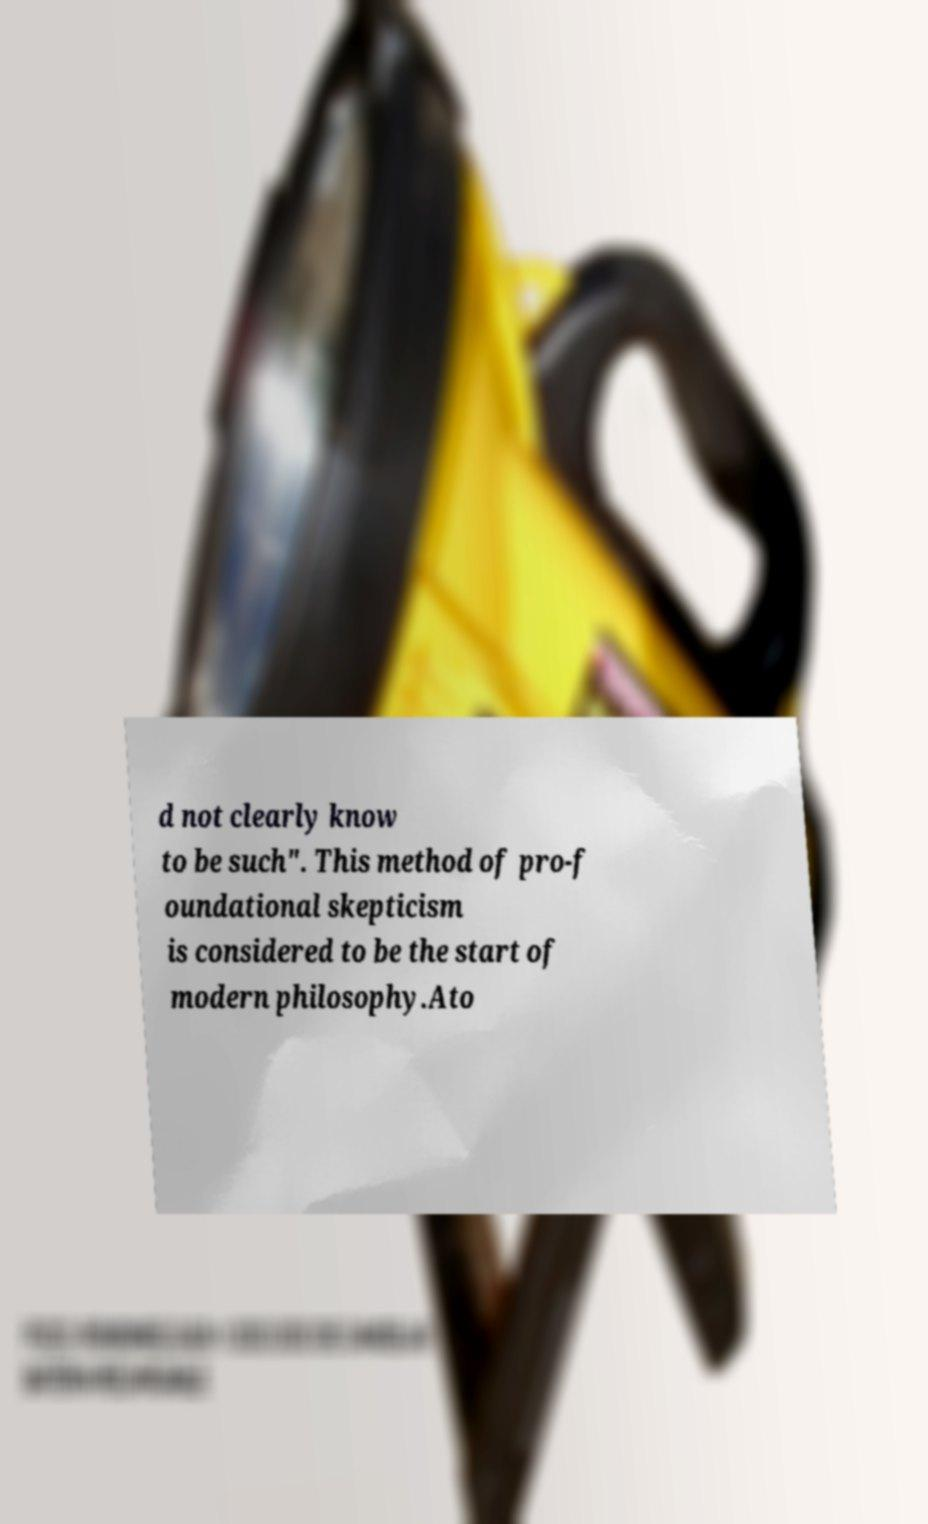I need the written content from this picture converted into text. Can you do that? d not clearly know to be such". This method of pro-f oundational skepticism is considered to be the start of modern philosophy.Ato 